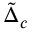<formula> <loc_0><loc_0><loc_500><loc_500>\tilde { \Delta } _ { c }</formula> 